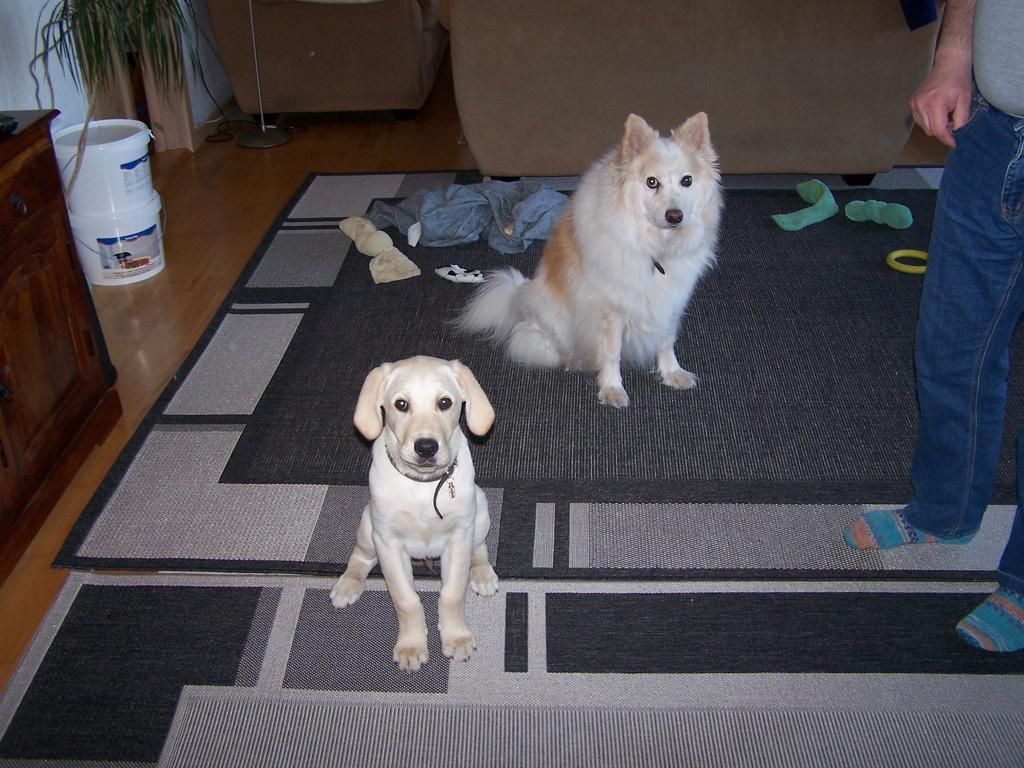Describe this image in one or two sentences. In this picture we can see two dogs, carpets, clothes, buckets, cupboard, plant, stand and these all are on the floor and a person standing and in the background we can see a sofa, chair. 